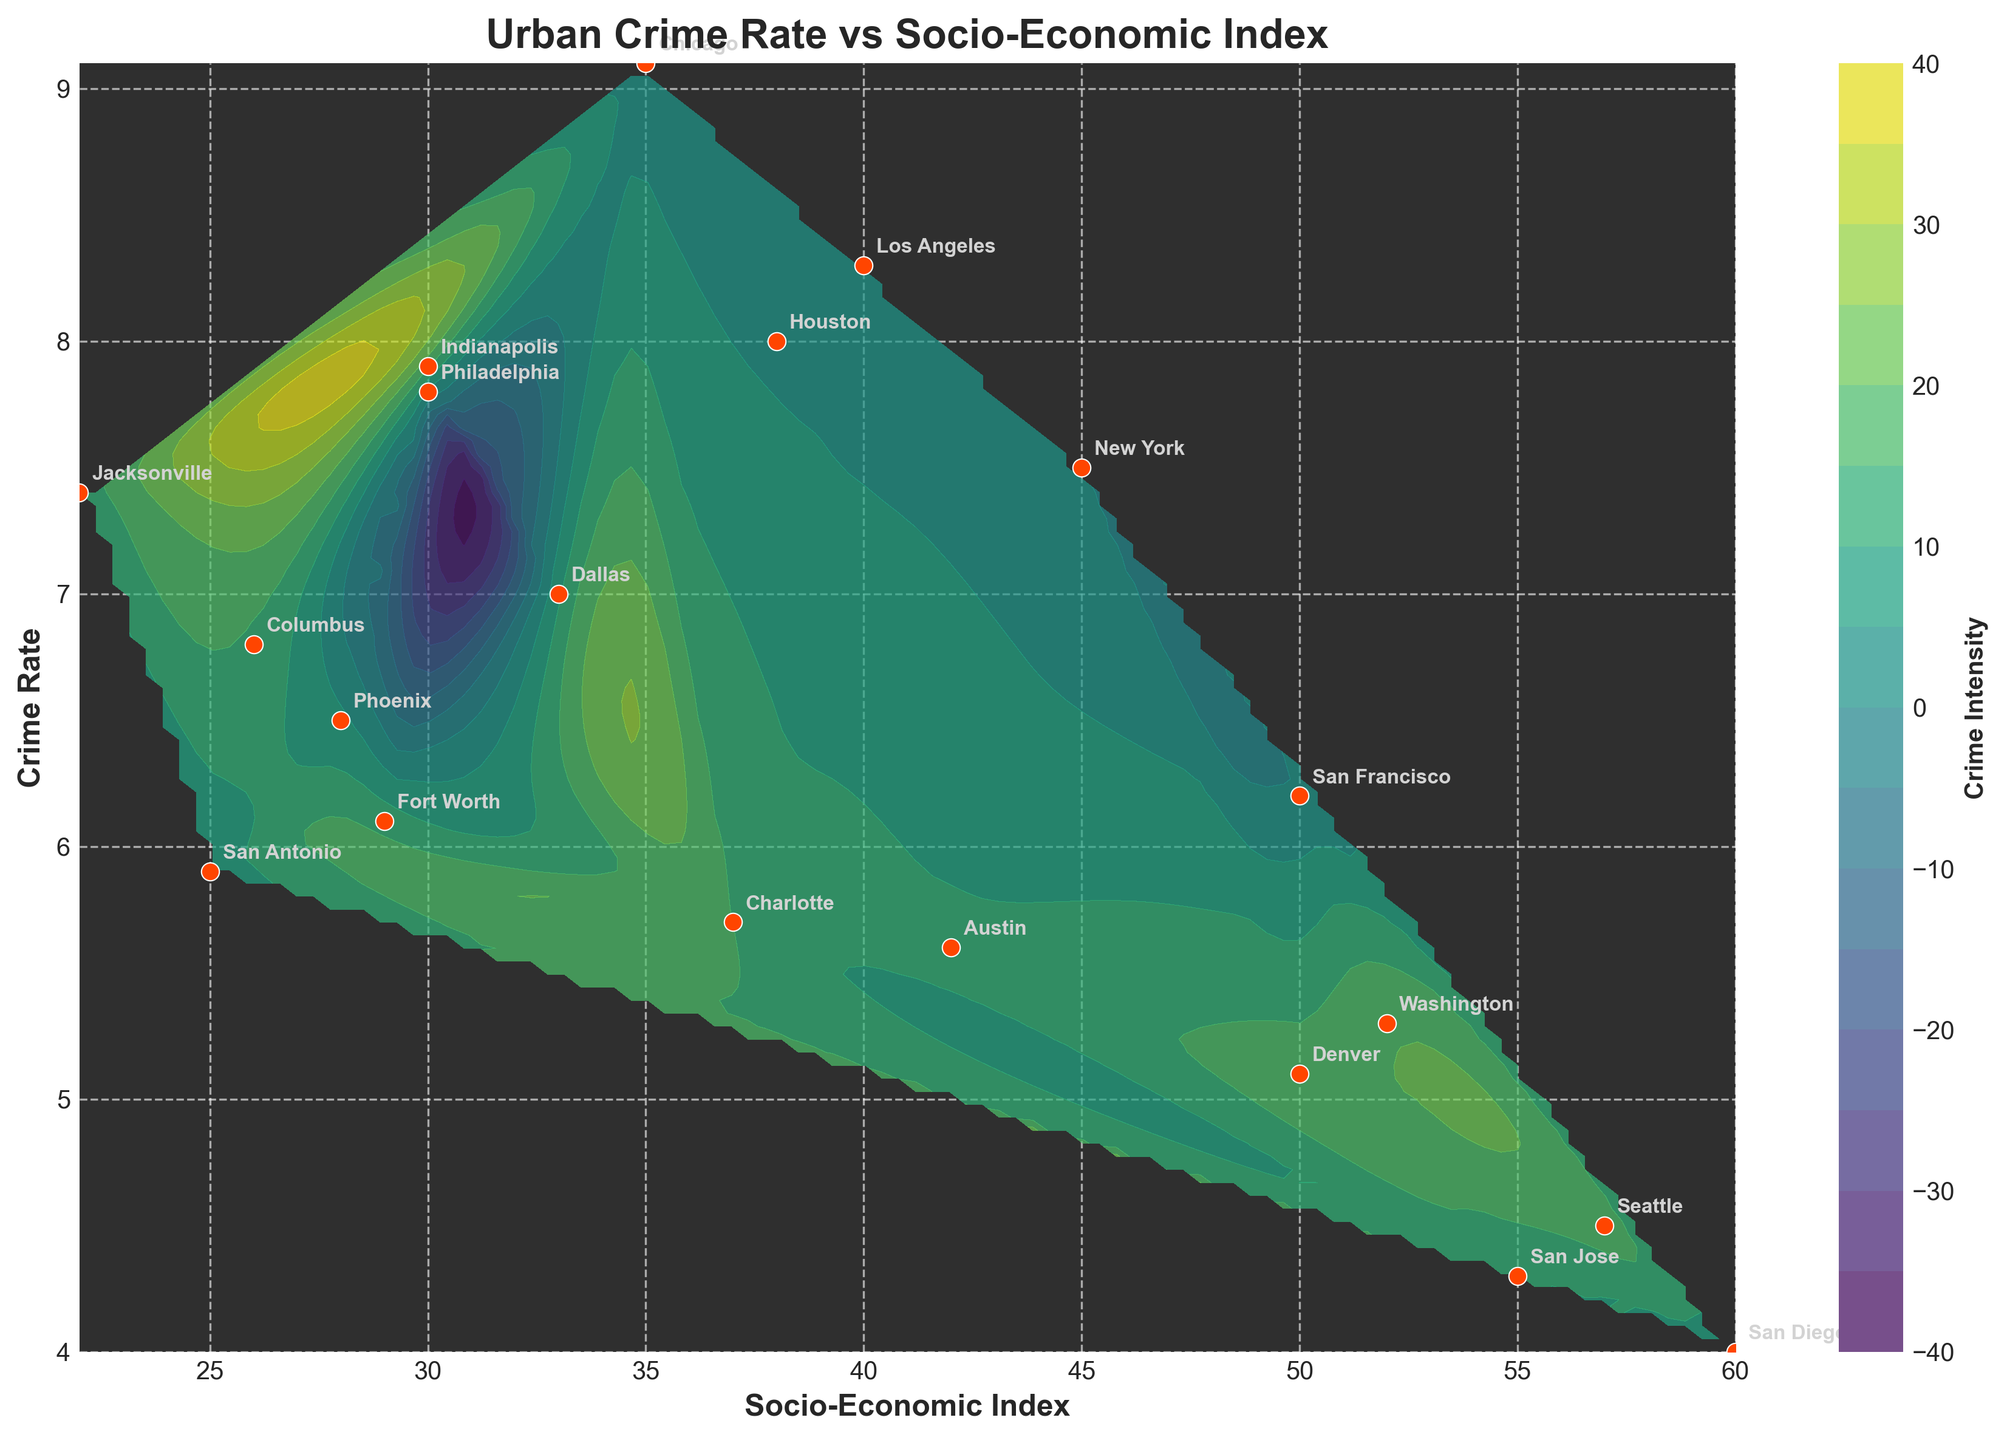What is the title of the plot? The title is usually displayed at the top of the plot, giving a clear indication of what the figure is about.
Answer: Urban Crime Rate vs Socio-Economic Index How many urban areas are represented in the plot? Each urban area listed in the data is represented by a point on the plot, which can be counted.
Answer: 20 Which urban area has the highest socio-economic index? Find the urban area at the highest position on the x-axis.
Answer: San Diego Which urban area has the highest crime rate? Find the urban area at the highest position on the y-axis.
Answer: Chicago Which two urban areas have very close crime rates but different socio-economic indexes? Two urban areas with similar y-values (crime rates) but different x-values (socio-economic indexes) should be identified.
Answer: Houston and Philadelphia Which urban area has the lowest crime rate? Find the urban area at the lowest position on the y-axis.
Answer: San Diego What is the socio-economic index range of New York and Los Angeles? Look at the x-axis positions of New York and Los Angeles and note their socio-economic indexes. The range is the difference between these indexes.
Answer: 5 Which urban area is marked closest to the center of the plot? The center of the plot can be estimated based on visual observation, and the urban area closest to this point can be identified.
Answer: Los Angeles How does crime intensity vary in relation to the socio-economic index based on contour levels? Examine the contour levels and their distribution to see how crime intensity changes with socio-economic index.
Answer: As socio-economic index increases, crime intensity tends to decrease What is the general trend between socio-economic index and crime rate? By observing the scatter plot and the general direction of the points, one can infer the trend.
Answer: Higher socio-economic index generally correlates with lower crime rates 